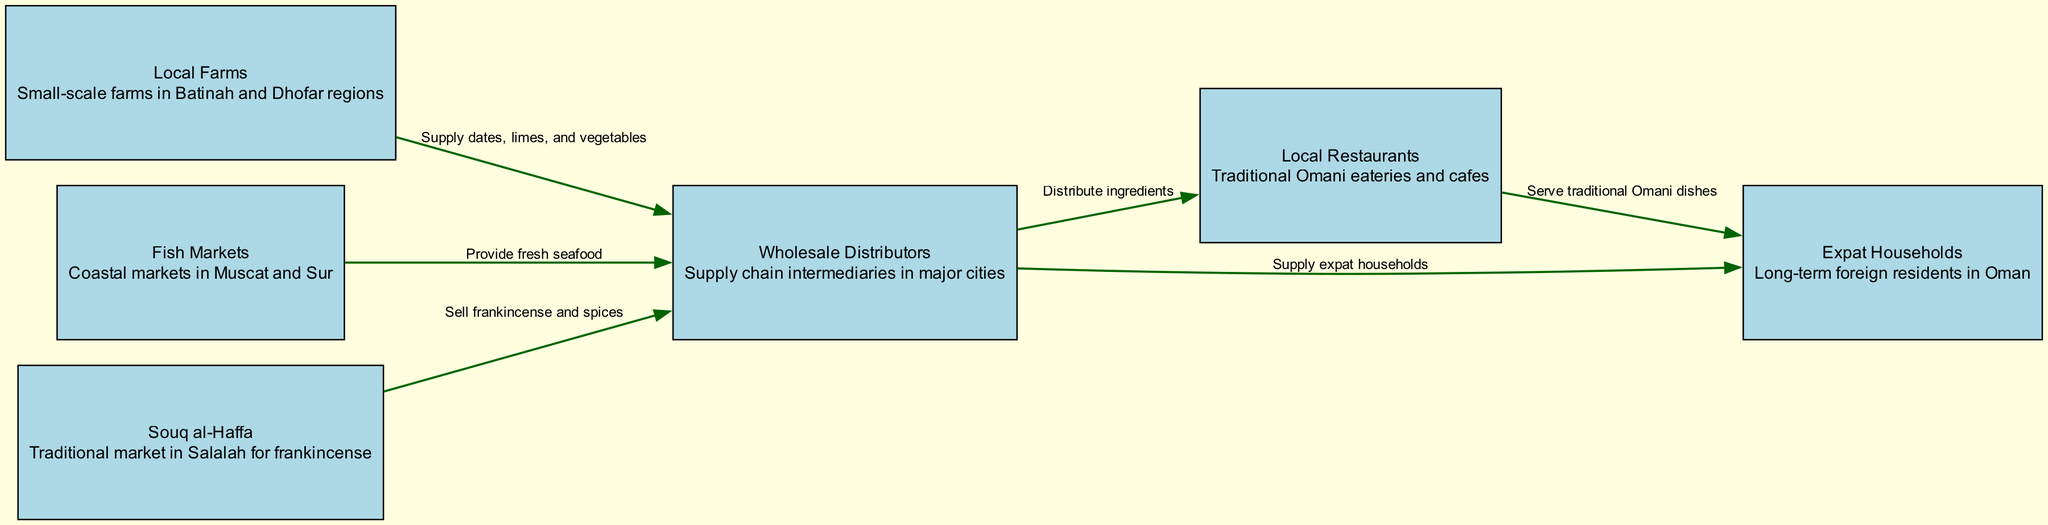What is the first step in the food chain? The first step in the food chain is "Local Farms," which refers to small-scale farms located in the Batinah and Dhofar regions producing various ingredients.
Answer: Local Farms How many nodes are present in the diagram? The diagram contains six nodes, which represent different stages and locations in the traditional Omani food chain.
Answer: 6 What do fish markets supply? Fish markets supply fresh seafood, which is obtained from coastal markets located in Muscat and Sur.
Answer: Fresh seafood Who do wholesale distributors supply? Wholesale distributors supply local restaurants and expat households, acting as intermediaries in the supply chain for traditional Omani cuisine.
Answer: Local restaurants and expat households What do local farms supply to wholesale distributors? Local farms supply dates, limes, and vegetables to wholesale distributors, which are then distributed further down the food chain.
Answer: Dates, limes, and vegetables What ingredient is specifically mentioned from Souq al-Haffa? The ingredient specifically mentioned from Souq al-Haffa is frankincense, which is a traditional product sold in this market located in Salalah.
Answer: Frankincense How do local restaurants operate in the food chain? Local restaurants receive ingredients from wholesale distributors and then serve traditional Omani dishes to expat households and other customers.
Answer: Serve traditional Omani dishes What is the relationship between local restaurants and expat households? The relationship is that local restaurants serve traditional Omani dishes to expat households, which are long-term foreign residents in Oman looking to enjoy local cuisine.
Answer: Serve traditional Omani dishes Which node connects to fish markets? Fish markets connect to wholesale distributors, which receive fresh seafood from the coastal markets for further distribution.
Answer: Wholesale Distributors 